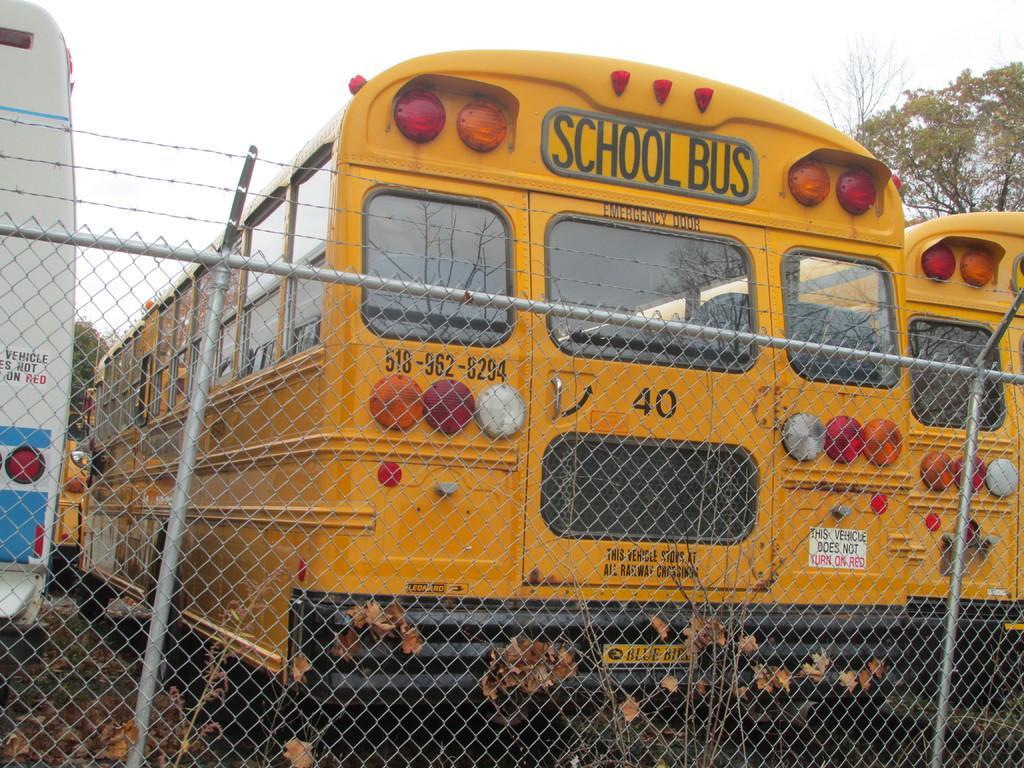How would you summarize this image in a sentence or two? In this picture I can see the net and metal rods in the middle, there are buses. In the background there are trees, at the top there is the sky. 